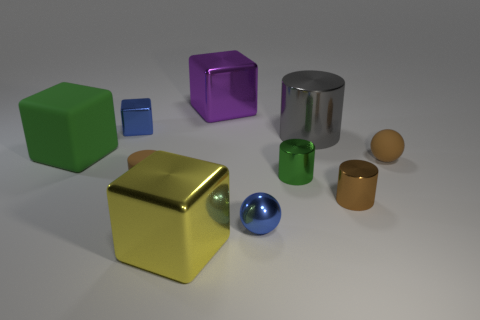Subtract all tiny green shiny cylinders. How many cylinders are left? 3 Subtract all green blocks. How many blocks are left? 3 Subtract all cubes. How many objects are left? 6 Subtract 2 cubes. How many cubes are left? 2 Subtract 0 yellow spheres. How many objects are left? 10 Subtract all red cubes. Subtract all gray cylinders. How many cubes are left? 4 Subtract all red balls. How many cyan cubes are left? 0 Subtract all brown shiny cylinders. Subtract all large gray metal balls. How many objects are left? 9 Add 3 brown rubber objects. How many brown rubber objects are left? 5 Add 5 large brown matte cubes. How many large brown matte cubes exist? 5 